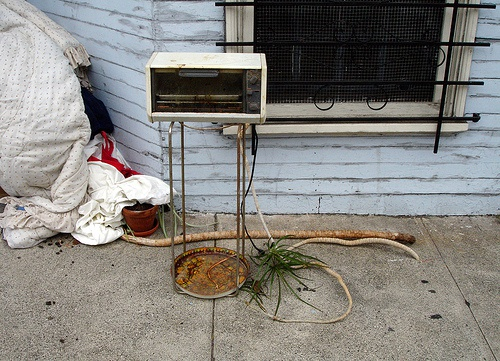Describe the objects in this image and their specific colors. I can see oven in darkgray, black, ivory, gray, and darkgreen tones and microwave in darkgray, black, ivory, gray, and darkgreen tones in this image. 